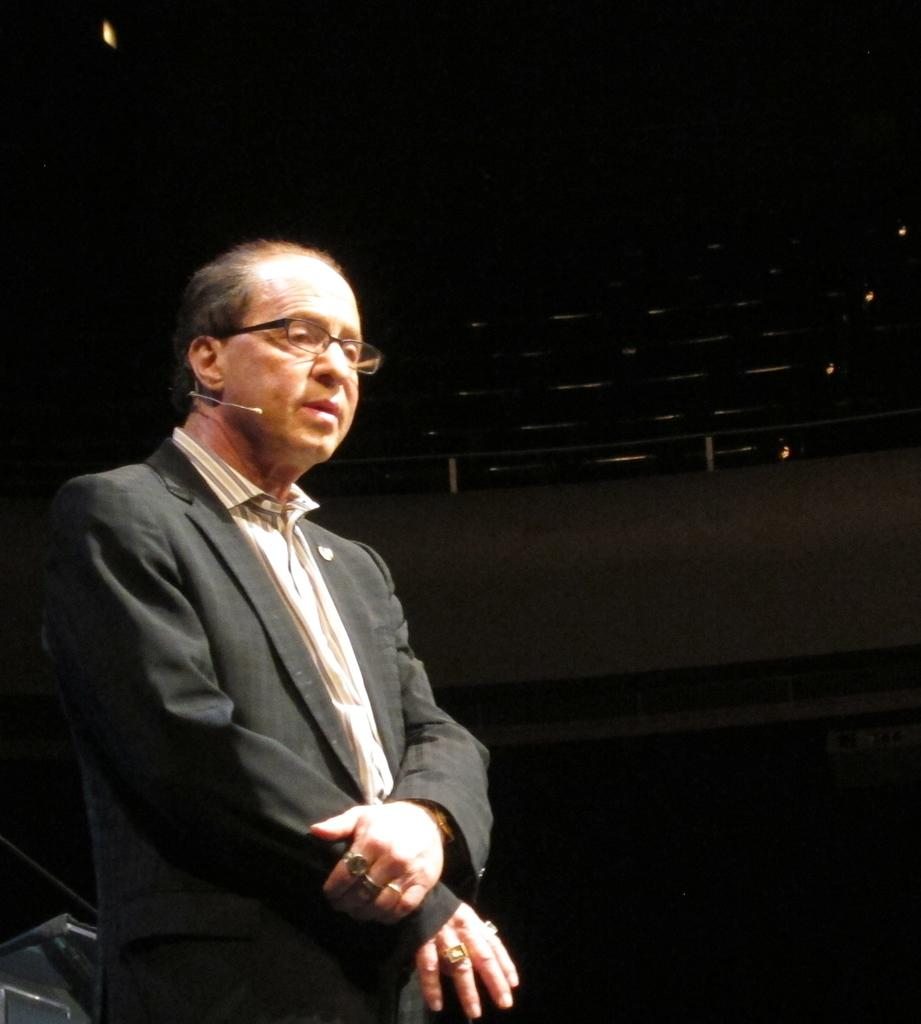What is the main subject of the image? The main subject of the image is a man. What is the man doing in the image? The man is standing in the image. What is the man wearing that helps him see better? The man is wearing spectacles in the image. What is the man holding in his hand? The man is holding a mic in the image. What can be observed about the lighting in the image? The background of the image is dark. What else can be seen in the background of the image? There are objects visible in the background. What type of memory does the man have in the image? There is no memory visible in the image; the man is wearing spectacles, which help him see better. What type of army is depicted in the image? There is no army present in the image; it features a man standing with a mic. 